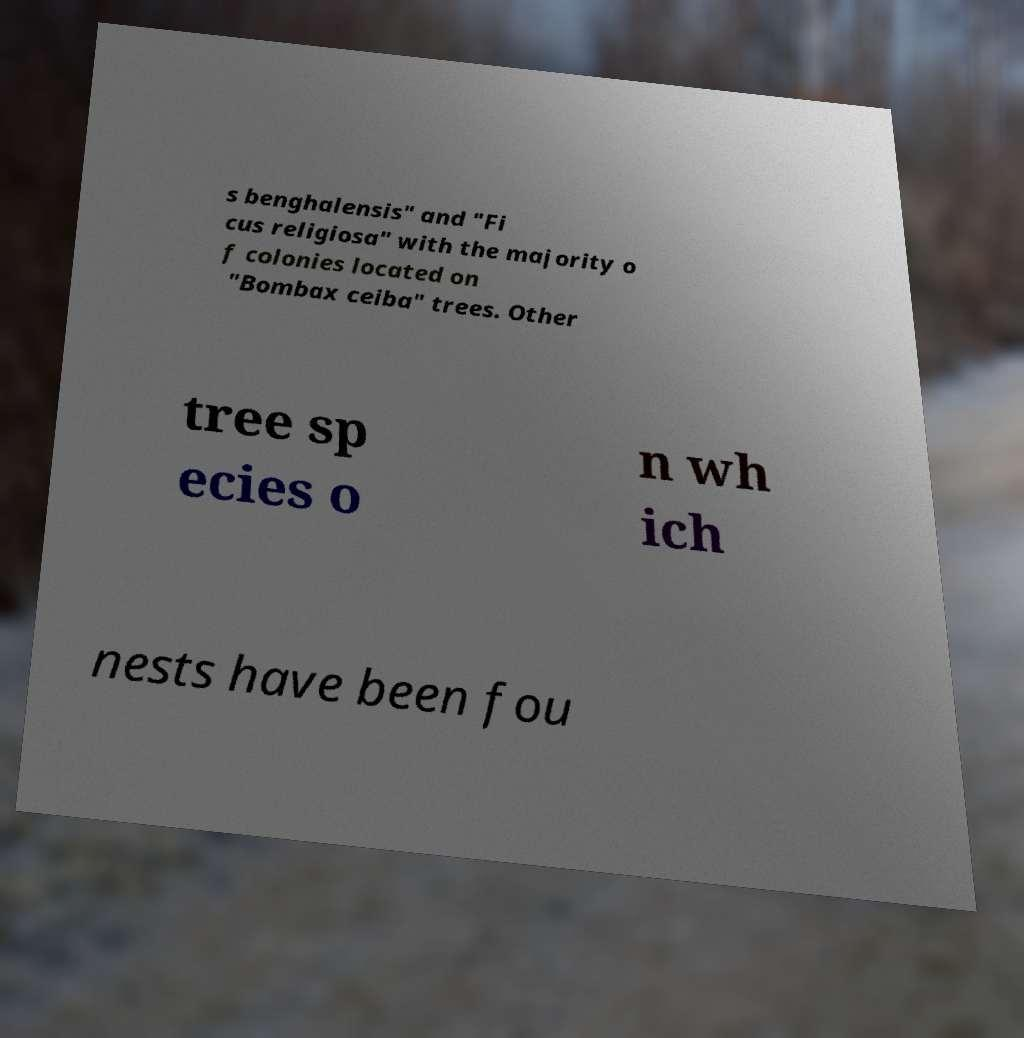Can you accurately transcribe the text from the provided image for me? s benghalensis" and "Fi cus religiosa" with the majority o f colonies located on "Bombax ceiba" trees. Other tree sp ecies o n wh ich nests have been fou 